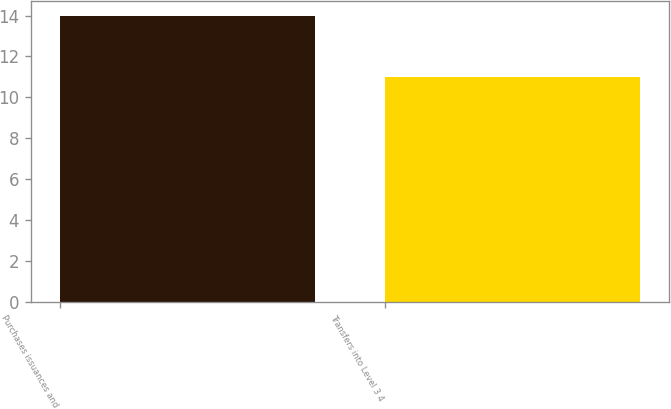Convert chart to OTSL. <chart><loc_0><loc_0><loc_500><loc_500><bar_chart><fcel>Purchases issuances and<fcel>Transfers into Level 3 4<nl><fcel>14<fcel>11<nl></chart> 